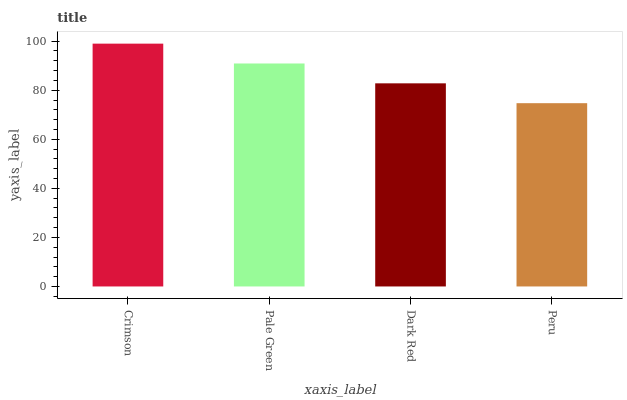Is Peru the minimum?
Answer yes or no. Yes. Is Crimson the maximum?
Answer yes or no. Yes. Is Pale Green the minimum?
Answer yes or no. No. Is Pale Green the maximum?
Answer yes or no. No. Is Crimson greater than Pale Green?
Answer yes or no. Yes. Is Pale Green less than Crimson?
Answer yes or no. Yes. Is Pale Green greater than Crimson?
Answer yes or no. No. Is Crimson less than Pale Green?
Answer yes or no. No. Is Pale Green the high median?
Answer yes or no. Yes. Is Dark Red the low median?
Answer yes or no. Yes. Is Crimson the high median?
Answer yes or no. No. Is Crimson the low median?
Answer yes or no. No. 